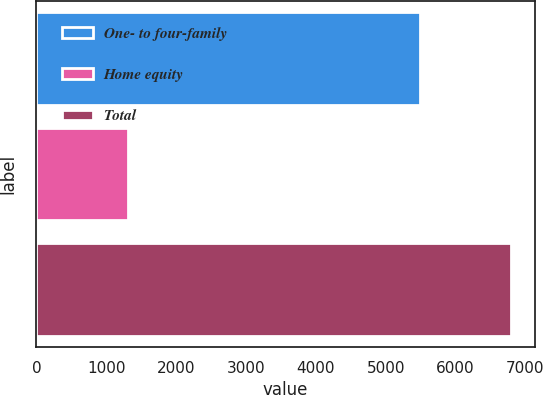<chart> <loc_0><loc_0><loc_500><loc_500><bar_chart><fcel>One- to four-family<fcel>Home equity<fcel>Total<nl><fcel>5487<fcel>1309<fcel>6796<nl></chart> 